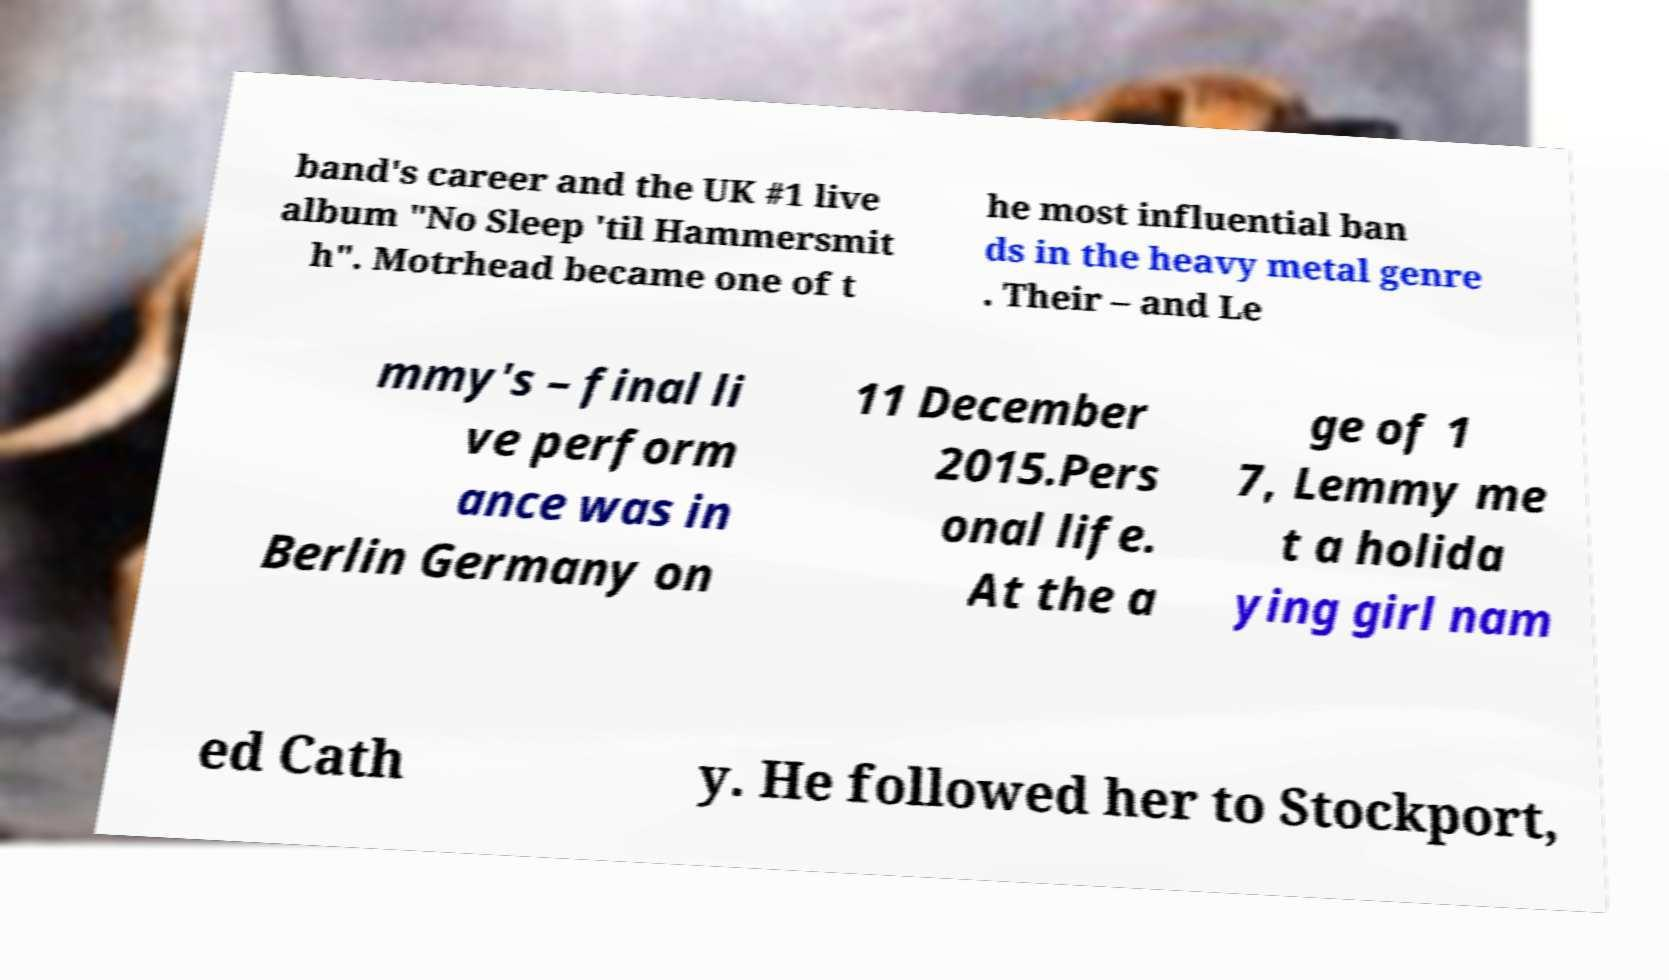I need the written content from this picture converted into text. Can you do that? band's career and the UK #1 live album "No Sleep 'til Hammersmit h". Motrhead became one of t he most influential ban ds in the heavy metal genre . Their – and Le mmy's – final li ve perform ance was in Berlin Germany on 11 December 2015.Pers onal life. At the a ge of 1 7, Lemmy me t a holida ying girl nam ed Cath y. He followed her to Stockport, 